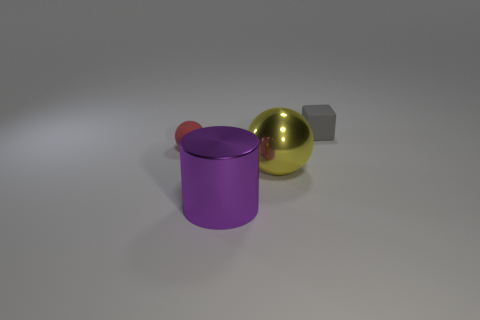Add 1 tiny red things. How many objects exist? 5 Subtract all red spheres. How many spheres are left? 1 Subtract all cubes. How many objects are left? 3 Subtract all red cubes. How many red spheres are left? 1 Subtract all large gray rubber cylinders. Subtract all yellow shiny balls. How many objects are left? 3 Add 2 yellow metallic balls. How many yellow metallic balls are left? 3 Add 4 metal things. How many metal things exist? 6 Subtract 0 purple blocks. How many objects are left? 4 Subtract 1 cylinders. How many cylinders are left? 0 Subtract all yellow balls. Subtract all red cylinders. How many balls are left? 1 